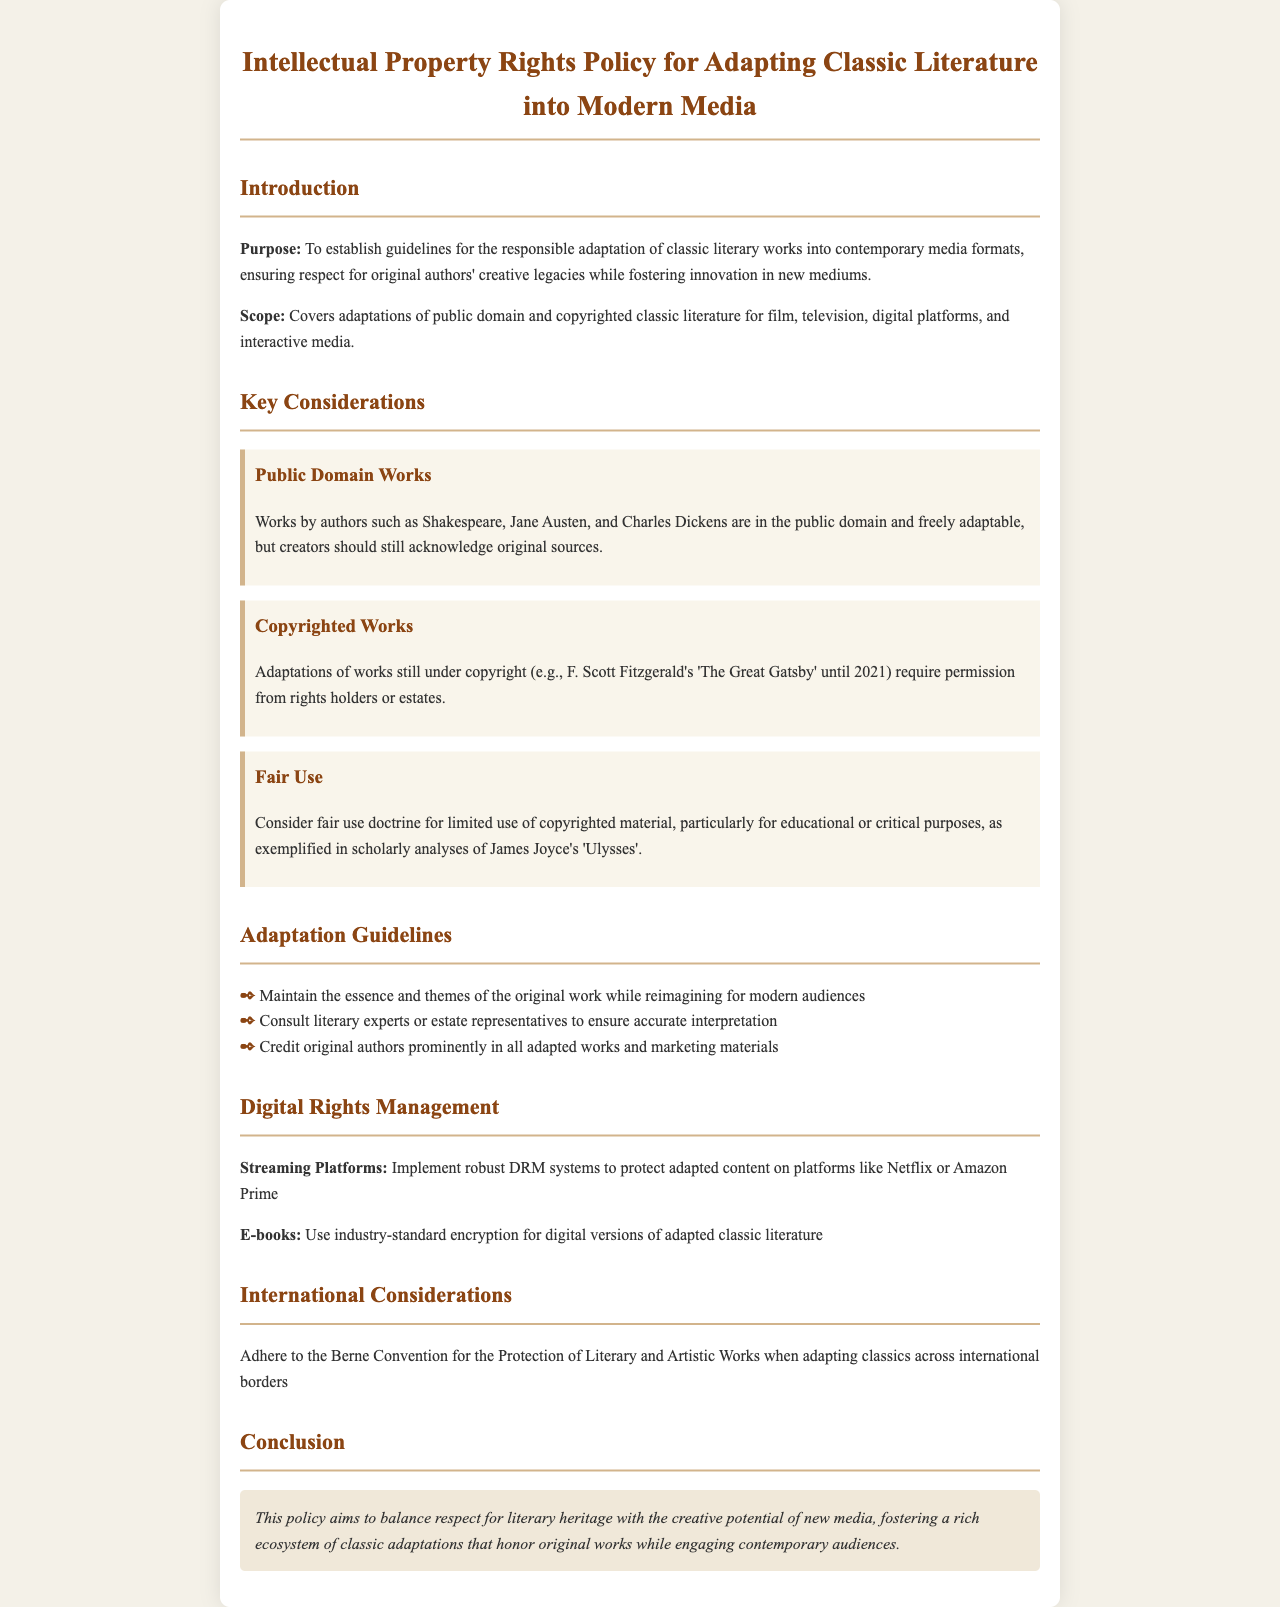What is the purpose of the policy? The purpose of the policy is to establish guidelines for the responsible adaptation of classic literary works into contemporary media formats while respecting original authors' legacies.
Answer: To establish guidelines for the responsible adaptation of classic literary works into contemporary media formats What works are in the public domain? Examples given in the document of authors whose works are in the public domain include Shakespeare, Jane Austen, and Charles Dickens.
Answer: Shakespeare, Jane Austen, and Charles Dickens What year did F. Scott Fitzgerald's 'The Great Gatsby' enter the public domain? The document states that 'The Great Gatsby' was under copyright until 2021.
Answer: 2021 What should creators do when adapting public domain works? According to the document, creators should acknowledge original sources when adapting works in the public domain.
Answer: Acknowledge original sources How many guidelines are listed for adaptations? The document lists three specific guidelines for adaptations.
Answer: Three What does DRM stand for in the context of this document? Digital Rights Management refers to the systems that need to be implemented to protect adapted content on streaming platforms.
Answer: Digital Rights Management What international agreement should be adhered to when adapting classics abroad? The document mentions adhering to the Berne Convention when adapting classics across international borders.
Answer: Berne Convention What is the main goal of the policy as stated in the conclusion? The policy aims to balance respect for literary heritage with the creative potential of new media.
Answer: Balance respect for literary heritage with the creative potential of new media 